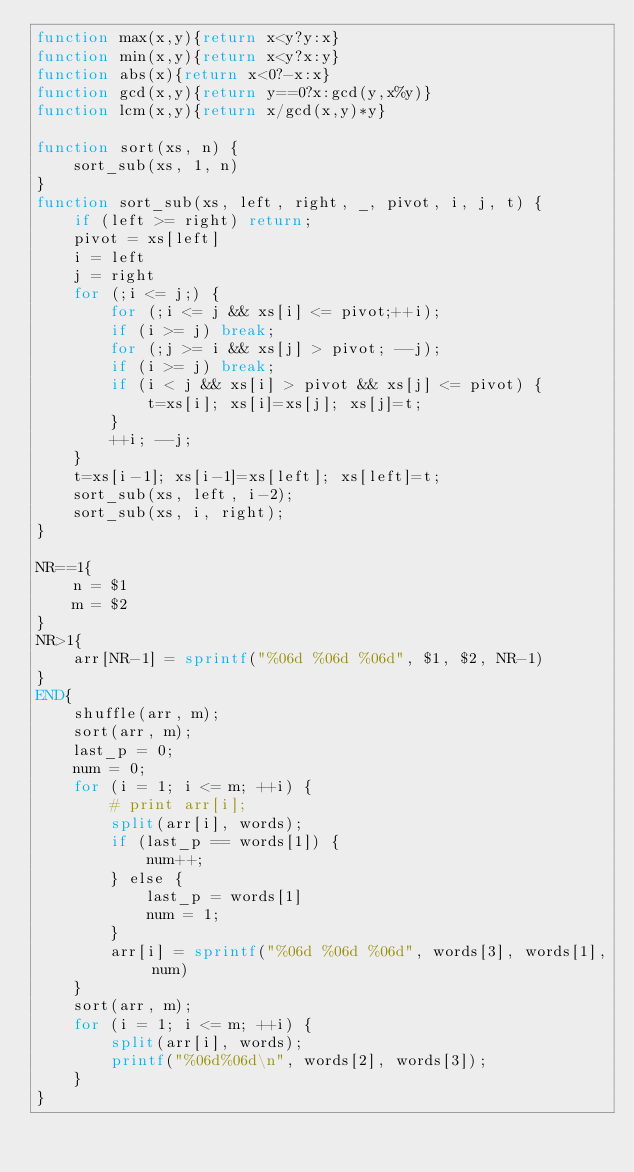<code> <loc_0><loc_0><loc_500><loc_500><_Awk_>function max(x,y){return x<y?y:x}
function min(x,y){return x<y?x:y}
function abs(x){return x<0?-x:x}
function gcd(x,y){return y==0?x:gcd(y,x%y)}
function lcm(x,y){return x/gcd(x,y)*y}

function sort(xs, n) {
    sort_sub(xs, 1, n)
}
function sort_sub(xs, left, right, _, pivot, i, j, t) {
    if (left >= right) return;
    pivot = xs[left]
    i = left
    j = right
    for (;i <= j;) {
        for (;i <= j && xs[i] <= pivot;++i);
        if (i >= j) break;
        for (;j >= i && xs[j] > pivot; --j);
        if (i >= j) break;
        if (i < j && xs[i] > pivot && xs[j] <= pivot) {
            t=xs[i]; xs[i]=xs[j]; xs[j]=t;
        }
        ++i; --j;
    }
    t=xs[i-1]; xs[i-1]=xs[left]; xs[left]=t;
    sort_sub(xs, left, i-2);
    sort_sub(xs, i, right);
}

NR==1{
    n = $1
    m = $2
}
NR>1{
    arr[NR-1] = sprintf("%06d %06d %06d", $1, $2, NR-1)
}
END{
    shuffle(arr, m);
    sort(arr, m);
    last_p = 0;
    num = 0;
    for (i = 1; i <= m; ++i) {
        # print arr[i];
        split(arr[i], words);
        if (last_p == words[1]) {
            num++;
        } else {
            last_p = words[1]
            num = 1;
        }
        arr[i] = sprintf("%06d %06d %06d", words[3], words[1], num)
    }
    sort(arr, m);
    for (i = 1; i <= m; ++i) {
        split(arr[i], words);
        printf("%06d%06d\n", words[2], words[3]);
    }
}
</code> 